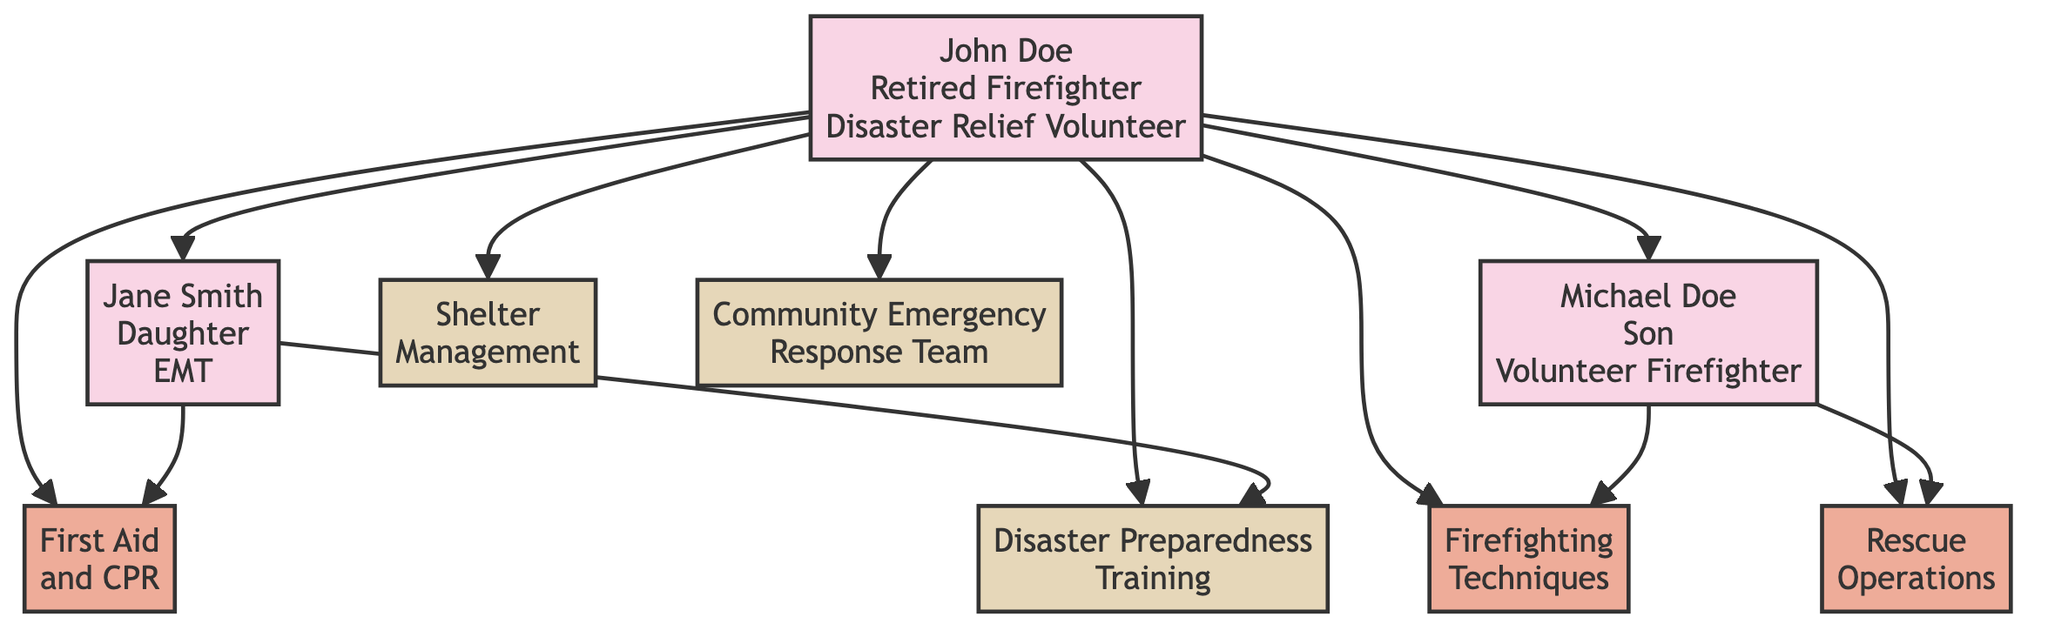What is the primary role of John Doe? The diagram indicates that John Doe has the role of "Retired Firefighter" and is also a "Disaster Relief Volunteer." Hence, the primary role can be deduced as "Retired Firefighter."
Answer: Retired Firefighter How many skills does John Doe have? By examining the diagram, John Doe is associated with three skills: Firefighting Techniques, Rescue Operations, and First Aid and CPR. Counting these gives a total of three skills.
Answer: 3 Who is Jane Smith's parent? The diagram links Jane Smith to John Doe with an arrow that indicates their relationship, making it clear that John Doe is her parent.
Answer: John Doe What relationship does Michael Doe have with John Doe? The diagram shows an arrow from John Doe to Michael Doe labeled with his name and indicates they are connected as father and son. Therefore, the relationship is "Son."
Answer: Son Which institution provided training in Shelter Management? The diagram links the training for Shelter Management specifically to the Federal Emergency Management Agency (FEMA). Therefore, this institution is responsible for that training.
Answer: Federal Emergency Management Agency (FEMA) What skills did Jane Smith acquire from her training? The diagram indicates that Jane Smith has acquired skills in First Aid and CPR and Disaster Preparedness Training, connecting her directly to these skill categories in the diagram.
Answer: First Aid and CPR, Disaster Preparedness Training Which role does Michael Doe have? According to the diagram, Michael Doe's role is stated as "Volunteer Firefighter," which is directly indicated on his node.
Answer: Volunteer Firefighter How many courses did John Doe complete? The diagram shows that John Doe completed three courses: Disaster Preparedness Training, Shelter Management, and Community Emergency Response Team (CERT). Therefore, the count is three courses.
Answer: 3 What skill does Jane Smith share with her father? The diagram reveals that both John Doe and Jane Smith possess the skill First Aid and CPR, linked from John Doe to Jane Smith. This shows that this skill is shared.
Answer: First Aid and CPR 